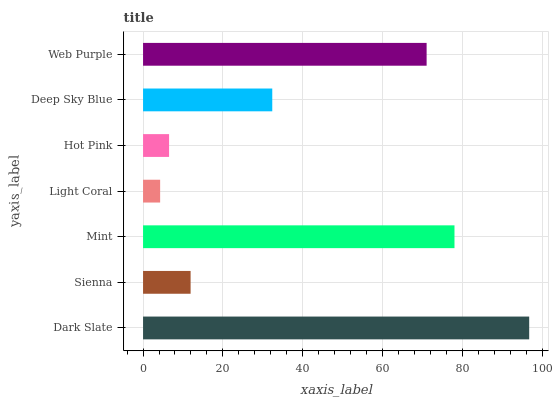Is Light Coral the minimum?
Answer yes or no. Yes. Is Dark Slate the maximum?
Answer yes or no. Yes. Is Sienna the minimum?
Answer yes or no. No. Is Sienna the maximum?
Answer yes or no. No. Is Dark Slate greater than Sienna?
Answer yes or no. Yes. Is Sienna less than Dark Slate?
Answer yes or no. Yes. Is Sienna greater than Dark Slate?
Answer yes or no. No. Is Dark Slate less than Sienna?
Answer yes or no. No. Is Deep Sky Blue the high median?
Answer yes or no. Yes. Is Deep Sky Blue the low median?
Answer yes or no. Yes. Is Web Purple the high median?
Answer yes or no. No. Is Light Coral the low median?
Answer yes or no. No. 